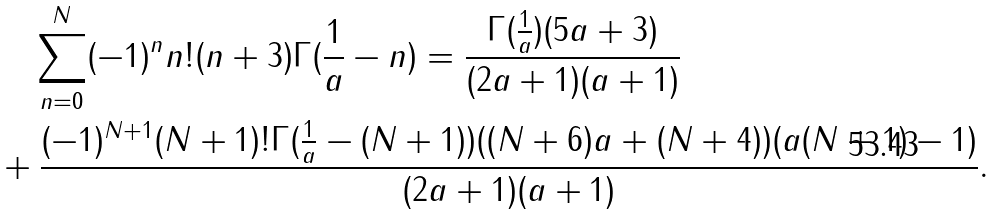<formula> <loc_0><loc_0><loc_500><loc_500>& \quad \sum _ { n = 0 } ^ { N } ( - 1 ) ^ { n } n ! ( n + 3 ) \Gamma ( \frac { 1 } { a } - n ) = \frac { \Gamma ( \frac { 1 } { a } ) ( 5 a + 3 ) } { ( 2 a + 1 ) ( a + 1 ) } \\ & + \frac { ( - 1 ) ^ { N + 1 } ( N + 1 ) ! \Gamma ( \frac { 1 } { a } - ( N + 1 ) ) ( ( N + 6 ) a + ( N + 4 ) ) ( a ( N + 1 ) - 1 ) } { ( 2 a + 1 ) ( a + 1 ) } .</formula> 